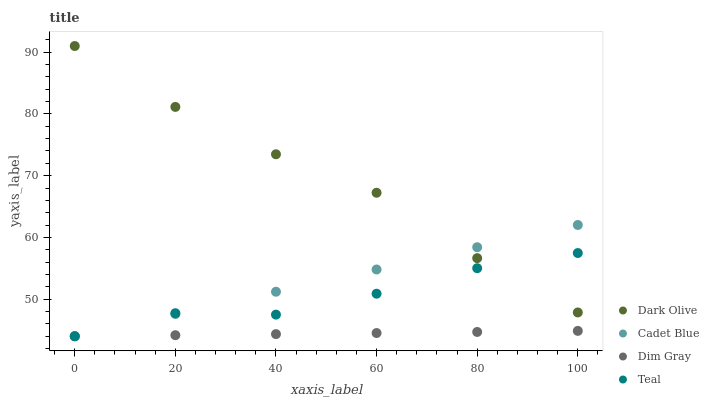Does Dim Gray have the minimum area under the curve?
Answer yes or no. Yes. Does Dark Olive have the maximum area under the curve?
Answer yes or no. Yes. Does Dark Olive have the minimum area under the curve?
Answer yes or no. No. Does Dim Gray have the maximum area under the curve?
Answer yes or no. No. Is Dim Gray the smoothest?
Answer yes or no. Yes. Is Teal the roughest?
Answer yes or no. Yes. Is Dark Olive the smoothest?
Answer yes or no. No. Is Dark Olive the roughest?
Answer yes or no. No. Does Cadet Blue have the lowest value?
Answer yes or no. Yes. Does Dark Olive have the lowest value?
Answer yes or no. No. Does Dark Olive have the highest value?
Answer yes or no. Yes. Does Dim Gray have the highest value?
Answer yes or no. No. Is Dim Gray less than Dark Olive?
Answer yes or no. Yes. Is Dark Olive greater than Dim Gray?
Answer yes or no. Yes. Does Dark Olive intersect Cadet Blue?
Answer yes or no. Yes. Is Dark Olive less than Cadet Blue?
Answer yes or no. No. Is Dark Olive greater than Cadet Blue?
Answer yes or no. No. Does Dim Gray intersect Dark Olive?
Answer yes or no. No. 